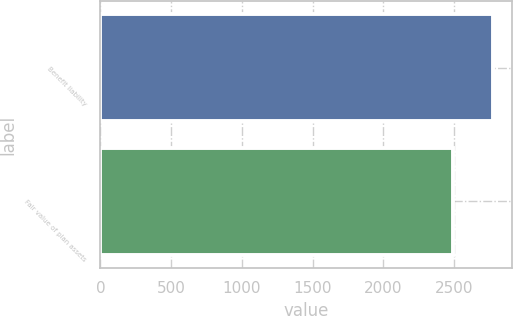Convert chart. <chart><loc_0><loc_0><loc_500><loc_500><bar_chart><fcel>Benefit liability<fcel>Fair value of plan assets<nl><fcel>2773<fcel>2492<nl></chart> 